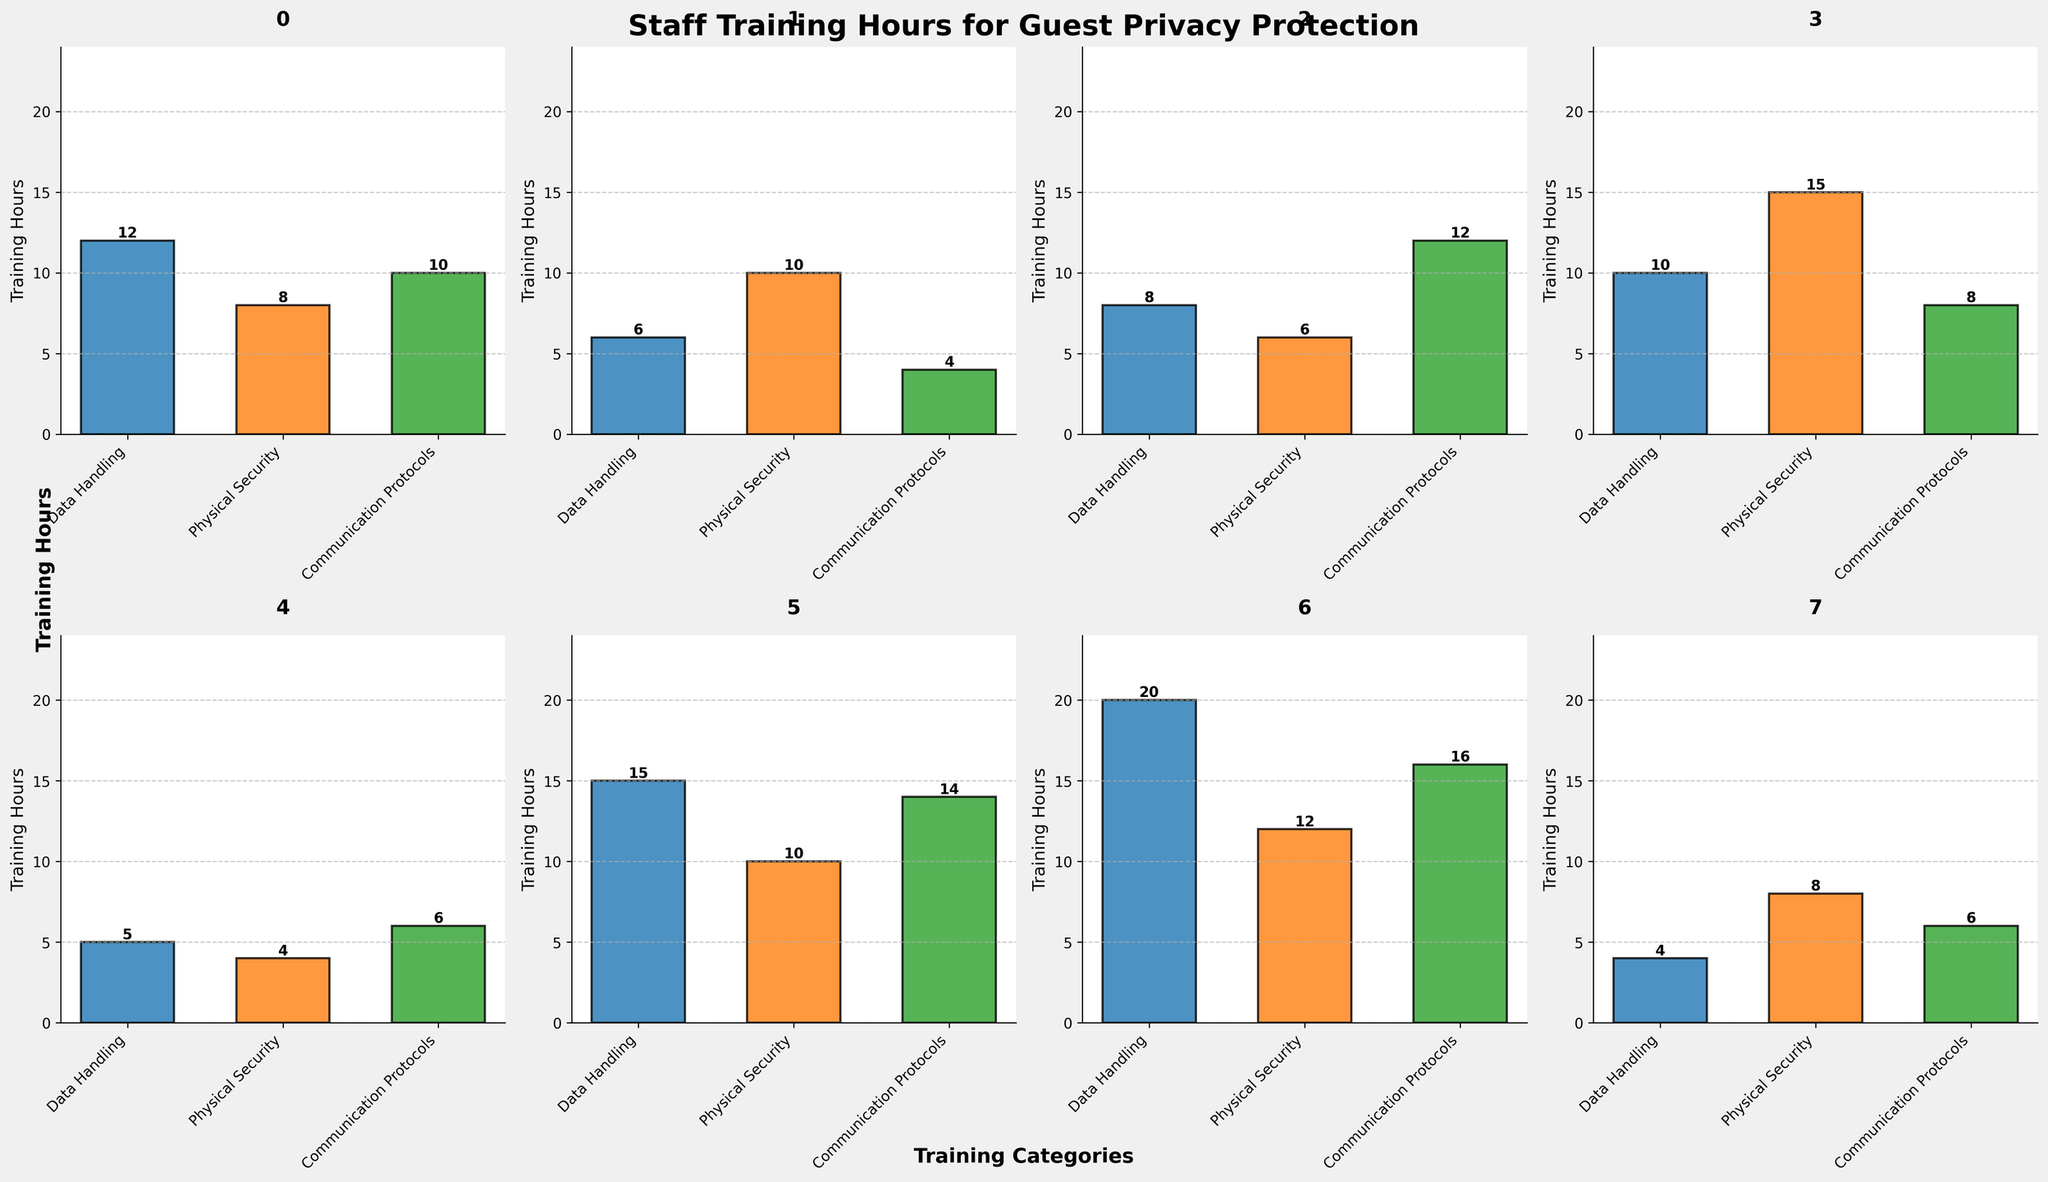What are the training hours dedicated to Data Handling for the IT department? Look at the subplot for the IT department and note the value of the bar corresponding to Data Handling.
Answer: 20 Which department has the highest training hours for Physical Security? Compare the bar heights for Physical Security across all subplots. The Security department has the tallest bar.
Answer: Security What is the total number of training hours for the Front Desk across all categories? Add the training hours for Data Handling, Physical Security, and Communication Protocols for the Front Desk: 12 + 8 + 10.
Answer: 30 Which department has fewer training hours for Communication Protocols, Food & Beverage or Housekeeping? Compare the bar heights for Communication Protocols between Food & Beverage (6 hours) and Housekeeping (4 hours). Housekeeping has fewer hours.
Answer: Housekeeping What is the average training hours for Communication Protocols across all departments? Sum the Communication Protocols training hours for all departments: 10 + 4 + 12 + 8 + 6 + 14 + 16 + 6 = 76. There are 8 departments, so the average is 76/8.
Answer: 9.5 How many departments have equal or more training hours for Physical Security than the Front Desk? The Front Desk has 8 hours for Physical Security. Count the departments with training hours ≥ 8: Housekeeping (10), Security (15), Management (10), IT (12), Valet (8). There are 5 such departments.
Answer: 5 What is the difference in training hours for Data Handling between Management and Concierge? Subtract the training hours for Data Handling for Concierge (8) from those for Management (15).
Answer: 7 For which category did the Valet department spend the most training hours? Look at the three bars in the Valet department's subplot and identify the tallest bar. The tallest bar corresponds to Physical Security.
Answer: Physical Security What is the sum of training hours for Physical Security for the Front Desk, Housekeeping, and Security departments? Sum the Physical Security training hours for Front Desk, Housekeeping, and Security: 8 + 10 + 15.
Answer: 33 What is the total number of training hours across all departments for Data Handling? Sum the Data Handling training hours for all departments: 12 + 6 + 8 + 10 + 5 + 15 + 20 + 4.
Answer: 80 